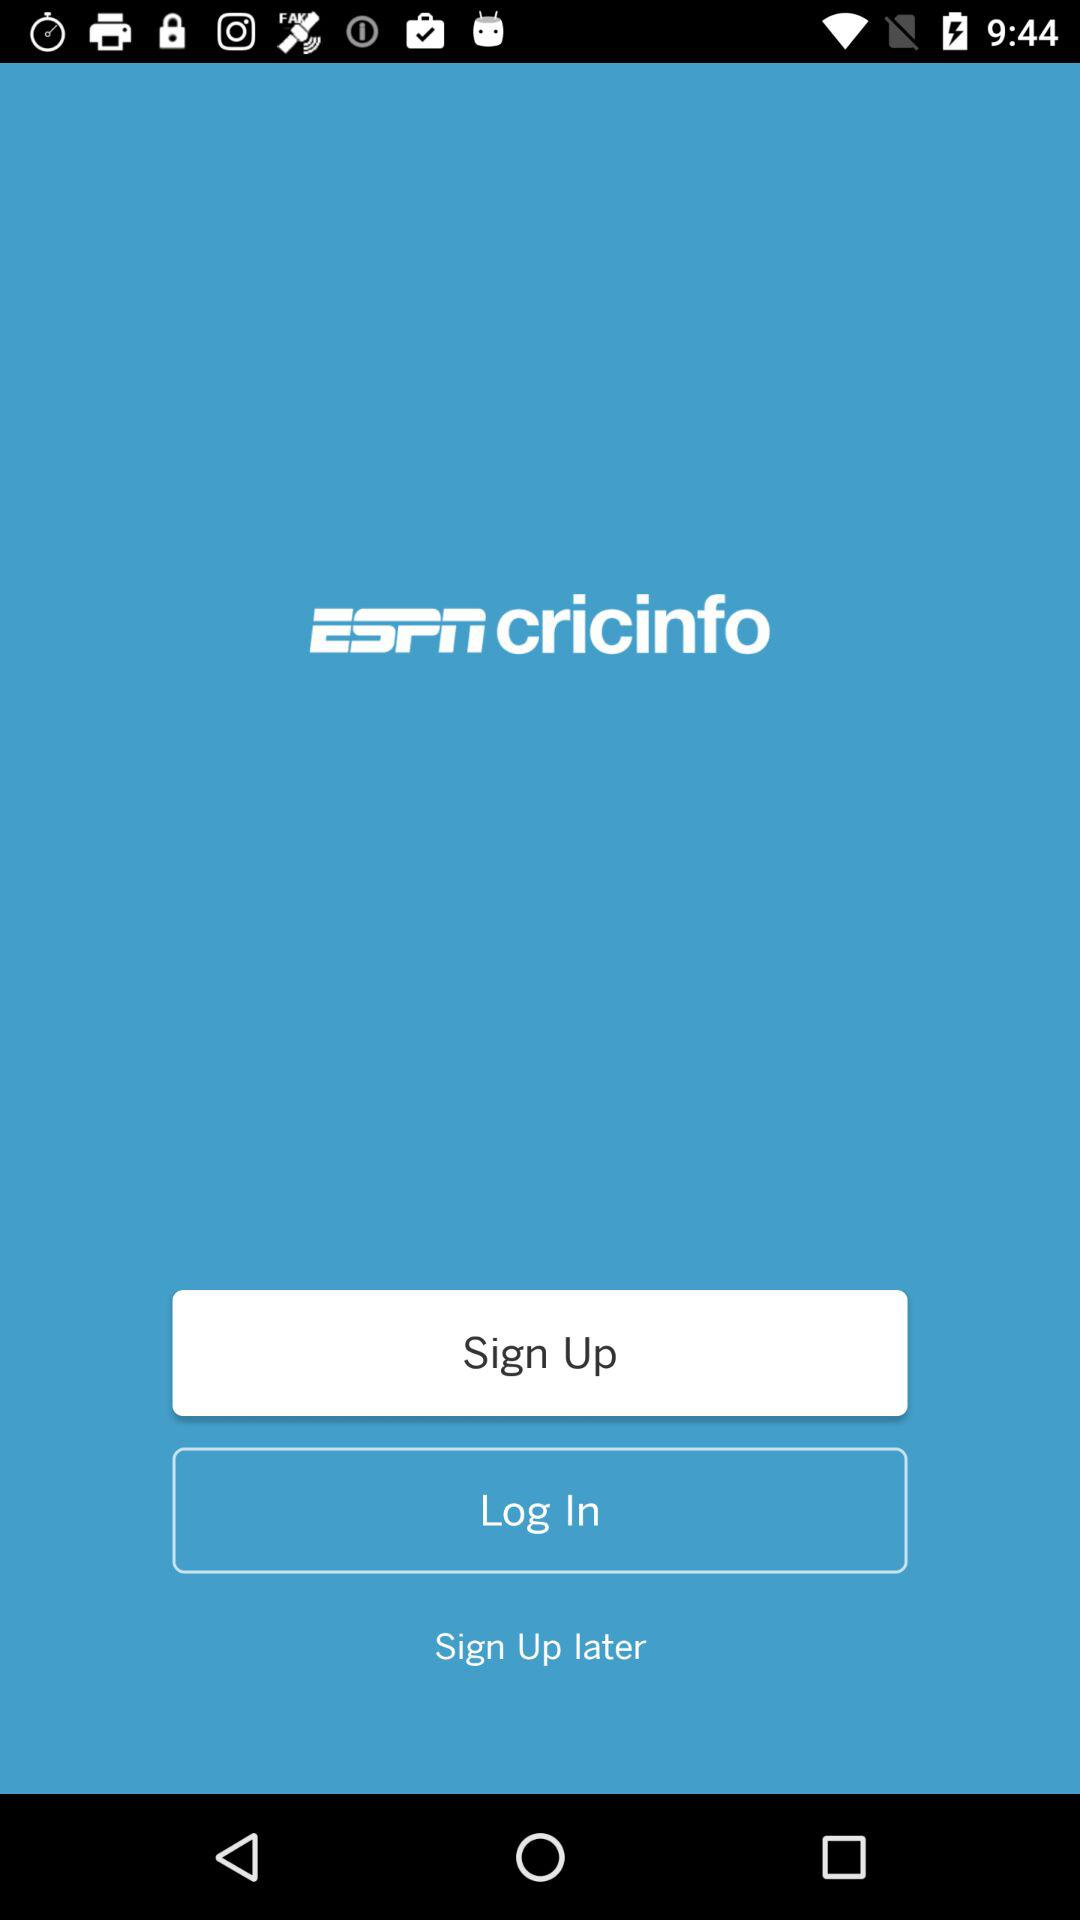What is the app name?
Answer the question using a single word or phrase. The app name is "ESPN cricinfo" 